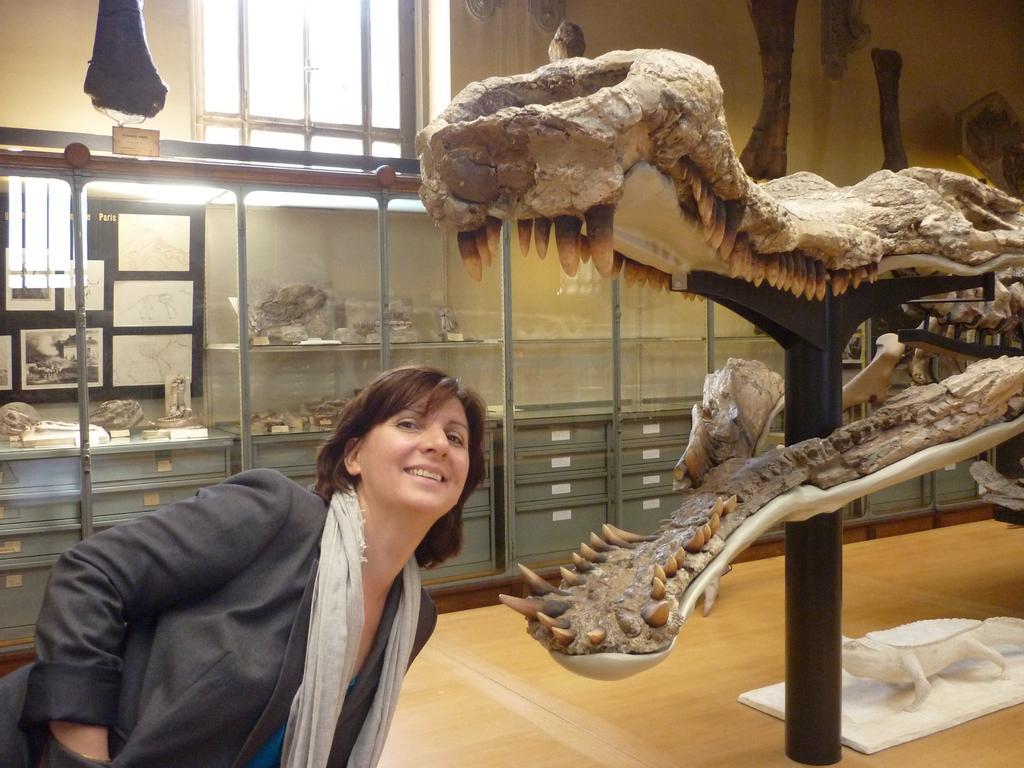Please provide a concise description of this image. In this picture there is a woman who is wearing black dress. She is standing near to the dinosaurs skull. Here we can see black holder. In the back we can see glass, papers, box and other objects. On the top there is a window. 